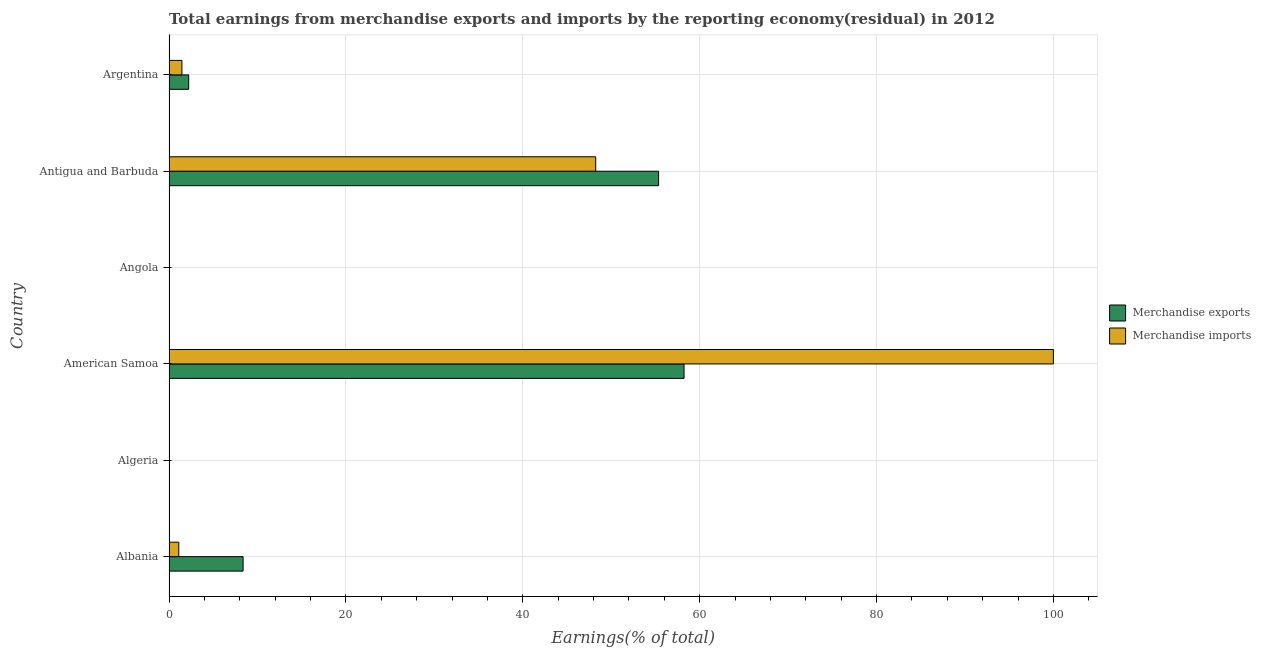How many different coloured bars are there?
Offer a very short reply. 2. How many bars are there on the 6th tick from the top?
Make the answer very short. 2. What is the label of the 2nd group of bars from the top?
Give a very brief answer. Antigua and Barbuda. In how many cases, is the number of bars for a given country not equal to the number of legend labels?
Make the answer very short. 1. What is the earnings from merchandise exports in Albania?
Offer a terse response. 8.38. Across all countries, what is the maximum earnings from merchandise exports?
Provide a short and direct response. 58.24. Across all countries, what is the minimum earnings from merchandise imports?
Provide a succinct answer. 0. In which country was the earnings from merchandise imports maximum?
Your answer should be compact. American Samoa. What is the total earnings from merchandise imports in the graph?
Provide a succinct answer. 150.83. What is the difference between the earnings from merchandise exports in Albania and that in Argentina?
Provide a succinct answer. 6.15. What is the difference between the earnings from merchandise imports in Albania and the earnings from merchandise exports in American Samoa?
Provide a succinct answer. -57.13. What is the average earnings from merchandise imports per country?
Your answer should be compact. 25.14. What is the difference between the earnings from merchandise exports and earnings from merchandise imports in Antigua and Barbuda?
Make the answer very short. 7.11. In how many countries, is the earnings from merchandise imports greater than 8 %?
Provide a short and direct response. 2. What is the ratio of the earnings from merchandise imports in Algeria to that in Angola?
Keep it short and to the point. 22.09. What is the difference between the highest and the second highest earnings from merchandise imports?
Make the answer very short. 51.75. What is the difference between the highest and the lowest earnings from merchandise exports?
Give a very brief answer. 58.24. In how many countries, is the earnings from merchandise imports greater than the average earnings from merchandise imports taken over all countries?
Offer a very short reply. 2. How many bars are there?
Make the answer very short. 11. Are all the bars in the graph horizontal?
Make the answer very short. Yes. How many countries are there in the graph?
Offer a very short reply. 6. What is the difference between two consecutive major ticks on the X-axis?
Provide a short and direct response. 20. Are the values on the major ticks of X-axis written in scientific E-notation?
Keep it short and to the point. No. Does the graph contain any zero values?
Your response must be concise. Yes. Does the graph contain grids?
Give a very brief answer. Yes. Where does the legend appear in the graph?
Offer a very short reply. Center right. How many legend labels are there?
Keep it short and to the point. 2. What is the title of the graph?
Your answer should be compact. Total earnings from merchandise exports and imports by the reporting economy(residual) in 2012. Does "Death rate" appear as one of the legend labels in the graph?
Ensure brevity in your answer.  No. What is the label or title of the X-axis?
Ensure brevity in your answer.  Earnings(% of total). What is the label or title of the Y-axis?
Offer a very short reply. Country. What is the Earnings(% of total) of Merchandise exports in Albania?
Offer a very short reply. 8.38. What is the Earnings(% of total) in Merchandise imports in Albania?
Ensure brevity in your answer.  1.11. What is the Earnings(% of total) of Merchandise imports in Algeria?
Provide a succinct answer. 0.02. What is the Earnings(% of total) in Merchandise exports in American Samoa?
Your answer should be very brief. 58.24. What is the Earnings(% of total) of Merchandise imports in American Samoa?
Offer a very short reply. 100. What is the Earnings(% of total) in Merchandise exports in Angola?
Make the answer very short. 2.792152107272631e-9. What is the Earnings(% of total) of Merchandise imports in Angola?
Provide a short and direct response. 0. What is the Earnings(% of total) in Merchandise exports in Antigua and Barbuda?
Your answer should be very brief. 55.36. What is the Earnings(% of total) of Merchandise imports in Antigua and Barbuda?
Provide a short and direct response. 48.25. What is the Earnings(% of total) in Merchandise exports in Argentina?
Keep it short and to the point. 2.23. What is the Earnings(% of total) of Merchandise imports in Argentina?
Give a very brief answer. 1.46. Across all countries, what is the maximum Earnings(% of total) of Merchandise exports?
Your response must be concise. 58.24. Across all countries, what is the minimum Earnings(% of total) in Merchandise imports?
Your answer should be compact. 0. What is the total Earnings(% of total) of Merchandise exports in the graph?
Offer a very short reply. 124.2. What is the total Earnings(% of total) of Merchandise imports in the graph?
Give a very brief answer. 150.83. What is the difference between the Earnings(% of total) of Merchandise imports in Albania and that in Algeria?
Make the answer very short. 1.09. What is the difference between the Earnings(% of total) of Merchandise exports in Albania and that in American Samoa?
Give a very brief answer. -49.86. What is the difference between the Earnings(% of total) in Merchandise imports in Albania and that in American Samoa?
Your answer should be compact. -98.89. What is the difference between the Earnings(% of total) of Merchandise exports in Albania and that in Angola?
Keep it short and to the point. 8.38. What is the difference between the Earnings(% of total) in Merchandise imports in Albania and that in Angola?
Your response must be concise. 1.11. What is the difference between the Earnings(% of total) in Merchandise exports in Albania and that in Antigua and Barbuda?
Your answer should be very brief. -46.98. What is the difference between the Earnings(% of total) of Merchandise imports in Albania and that in Antigua and Barbuda?
Offer a terse response. -47.14. What is the difference between the Earnings(% of total) in Merchandise exports in Albania and that in Argentina?
Make the answer very short. 6.15. What is the difference between the Earnings(% of total) in Merchandise imports in Albania and that in Argentina?
Your answer should be very brief. -0.35. What is the difference between the Earnings(% of total) of Merchandise imports in Algeria and that in American Samoa?
Offer a very short reply. -99.98. What is the difference between the Earnings(% of total) of Merchandise imports in Algeria and that in Angola?
Give a very brief answer. 0.01. What is the difference between the Earnings(% of total) in Merchandise imports in Algeria and that in Antigua and Barbuda?
Give a very brief answer. -48.24. What is the difference between the Earnings(% of total) in Merchandise imports in Algeria and that in Argentina?
Your response must be concise. -1.44. What is the difference between the Earnings(% of total) of Merchandise exports in American Samoa and that in Angola?
Make the answer very short. 58.24. What is the difference between the Earnings(% of total) of Merchandise imports in American Samoa and that in Angola?
Your response must be concise. 100. What is the difference between the Earnings(% of total) in Merchandise exports in American Samoa and that in Antigua and Barbuda?
Give a very brief answer. 2.88. What is the difference between the Earnings(% of total) in Merchandise imports in American Samoa and that in Antigua and Barbuda?
Your answer should be very brief. 51.75. What is the difference between the Earnings(% of total) in Merchandise exports in American Samoa and that in Argentina?
Offer a terse response. 56.01. What is the difference between the Earnings(% of total) of Merchandise imports in American Samoa and that in Argentina?
Your answer should be compact. 98.54. What is the difference between the Earnings(% of total) of Merchandise exports in Angola and that in Antigua and Barbuda?
Provide a succinct answer. -55.36. What is the difference between the Earnings(% of total) of Merchandise imports in Angola and that in Antigua and Barbuda?
Your answer should be compact. -48.25. What is the difference between the Earnings(% of total) of Merchandise exports in Angola and that in Argentina?
Offer a very short reply. -2.23. What is the difference between the Earnings(% of total) of Merchandise imports in Angola and that in Argentina?
Keep it short and to the point. -1.46. What is the difference between the Earnings(% of total) in Merchandise exports in Antigua and Barbuda and that in Argentina?
Provide a succinct answer. 53.13. What is the difference between the Earnings(% of total) of Merchandise imports in Antigua and Barbuda and that in Argentina?
Offer a terse response. 46.79. What is the difference between the Earnings(% of total) in Merchandise exports in Albania and the Earnings(% of total) in Merchandise imports in Algeria?
Give a very brief answer. 8.36. What is the difference between the Earnings(% of total) of Merchandise exports in Albania and the Earnings(% of total) of Merchandise imports in American Samoa?
Your answer should be compact. -91.62. What is the difference between the Earnings(% of total) in Merchandise exports in Albania and the Earnings(% of total) in Merchandise imports in Angola?
Your answer should be compact. 8.38. What is the difference between the Earnings(% of total) in Merchandise exports in Albania and the Earnings(% of total) in Merchandise imports in Antigua and Barbuda?
Your response must be concise. -39.87. What is the difference between the Earnings(% of total) of Merchandise exports in Albania and the Earnings(% of total) of Merchandise imports in Argentina?
Provide a short and direct response. 6.92. What is the difference between the Earnings(% of total) of Merchandise exports in American Samoa and the Earnings(% of total) of Merchandise imports in Angola?
Your answer should be compact. 58.24. What is the difference between the Earnings(% of total) of Merchandise exports in American Samoa and the Earnings(% of total) of Merchandise imports in Antigua and Barbuda?
Your answer should be very brief. 9.99. What is the difference between the Earnings(% of total) in Merchandise exports in American Samoa and the Earnings(% of total) in Merchandise imports in Argentina?
Give a very brief answer. 56.78. What is the difference between the Earnings(% of total) of Merchandise exports in Angola and the Earnings(% of total) of Merchandise imports in Antigua and Barbuda?
Your answer should be compact. -48.25. What is the difference between the Earnings(% of total) of Merchandise exports in Angola and the Earnings(% of total) of Merchandise imports in Argentina?
Keep it short and to the point. -1.46. What is the difference between the Earnings(% of total) of Merchandise exports in Antigua and Barbuda and the Earnings(% of total) of Merchandise imports in Argentina?
Keep it short and to the point. 53.9. What is the average Earnings(% of total) in Merchandise exports per country?
Give a very brief answer. 20.7. What is the average Earnings(% of total) in Merchandise imports per country?
Provide a short and direct response. 25.14. What is the difference between the Earnings(% of total) in Merchandise exports and Earnings(% of total) in Merchandise imports in Albania?
Provide a short and direct response. 7.27. What is the difference between the Earnings(% of total) in Merchandise exports and Earnings(% of total) in Merchandise imports in American Samoa?
Make the answer very short. -41.76. What is the difference between the Earnings(% of total) in Merchandise exports and Earnings(% of total) in Merchandise imports in Angola?
Your answer should be compact. -0. What is the difference between the Earnings(% of total) of Merchandise exports and Earnings(% of total) of Merchandise imports in Antigua and Barbuda?
Offer a very short reply. 7.11. What is the difference between the Earnings(% of total) of Merchandise exports and Earnings(% of total) of Merchandise imports in Argentina?
Offer a very short reply. 0.77. What is the ratio of the Earnings(% of total) in Merchandise imports in Albania to that in Algeria?
Give a very brief answer. 72.72. What is the ratio of the Earnings(% of total) of Merchandise exports in Albania to that in American Samoa?
Ensure brevity in your answer.  0.14. What is the ratio of the Earnings(% of total) of Merchandise imports in Albania to that in American Samoa?
Give a very brief answer. 0.01. What is the ratio of the Earnings(% of total) of Merchandise exports in Albania to that in Angola?
Ensure brevity in your answer.  3.00e+09. What is the ratio of the Earnings(% of total) of Merchandise imports in Albania to that in Angola?
Offer a terse response. 1606.09. What is the ratio of the Earnings(% of total) in Merchandise exports in Albania to that in Antigua and Barbuda?
Provide a short and direct response. 0.15. What is the ratio of the Earnings(% of total) of Merchandise imports in Albania to that in Antigua and Barbuda?
Give a very brief answer. 0.02. What is the ratio of the Earnings(% of total) in Merchandise exports in Albania to that in Argentina?
Your answer should be compact. 3.76. What is the ratio of the Earnings(% of total) in Merchandise imports in Albania to that in Argentina?
Your answer should be compact. 0.76. What is the ratio of the Earnings(% of total) in Merchandise imports in Algeria to that in Angola?
Keep it short and to the point. 22.09. What is the ratio of the Earnings(% of total) of Merchandise imports in Algeria to that in Antigua and Barbuda?
Provide a short and direct response. 0. What is the ratio of the Earnings(% of total) of Merchandise imports in Algeria to that in Argentina?
Ensure brevity in your answer.  0.01. What is the ratio of the Earnings(% of total) in Merchandise exports in American Samoa to that in Angola?
Offer a terse response. 2.09e+1. What is the ratio of the Earnings(% of total) in Merchandise imports in American Samoa to that in Angola?
Provide a short and direct response. 1.45e+05. What is the ratio of the Earnings(% of total) in Merchandise exports in American Samoa to that in Antigua and Barbuda?
Offer a terse response. 1.05. What is the ratio of the Earnings(% of total) in Merchandise imports in American Samoa to that in Antigua and Barbuda?
Provide a succinct answer. 2.07. What is the ratio of the Earnings(% of total) of Merchandise exports in American Samoa to that in Argentina?
Give a very brief answer. 26.16. What is the ratio of the Earnings(% of total) of Merchandise imports in American Samoa to that in Argentina?
Your answer should be very brief. 68.53. What is the ratio of the Earnings(% of total) in Merchandise imports in Angola to that in Argentina?
Your answer should be compact. 0. What is the ratio of the Earnings(% of total) in Merchandise exports in Antigua and Barbuda to that in Argentina?
Offer a terse response. 24.87. What is the ratio of the Earnings(% of total) in Merchandise imports in Antigua and Barbuda to that in Argentina?
Give a very brief answer. 33.07. What is the difference between the highest and the second highest Earnings(% of total) in Merchandise exports?
Make the answer very short. 2.88. What is the difference between the highest and the second highest Earnings(% of total) in Merchandise imports?
Your response must be concise. 51.75. What is the difference between the highest and the lowest Earnings(% of total) of Merchandise exports?
Offer a terse response. 58.24. What is the difference between the highest and the lowest Earnings(% of total) of Merchandise imports?
Offer a terse response. 100. 